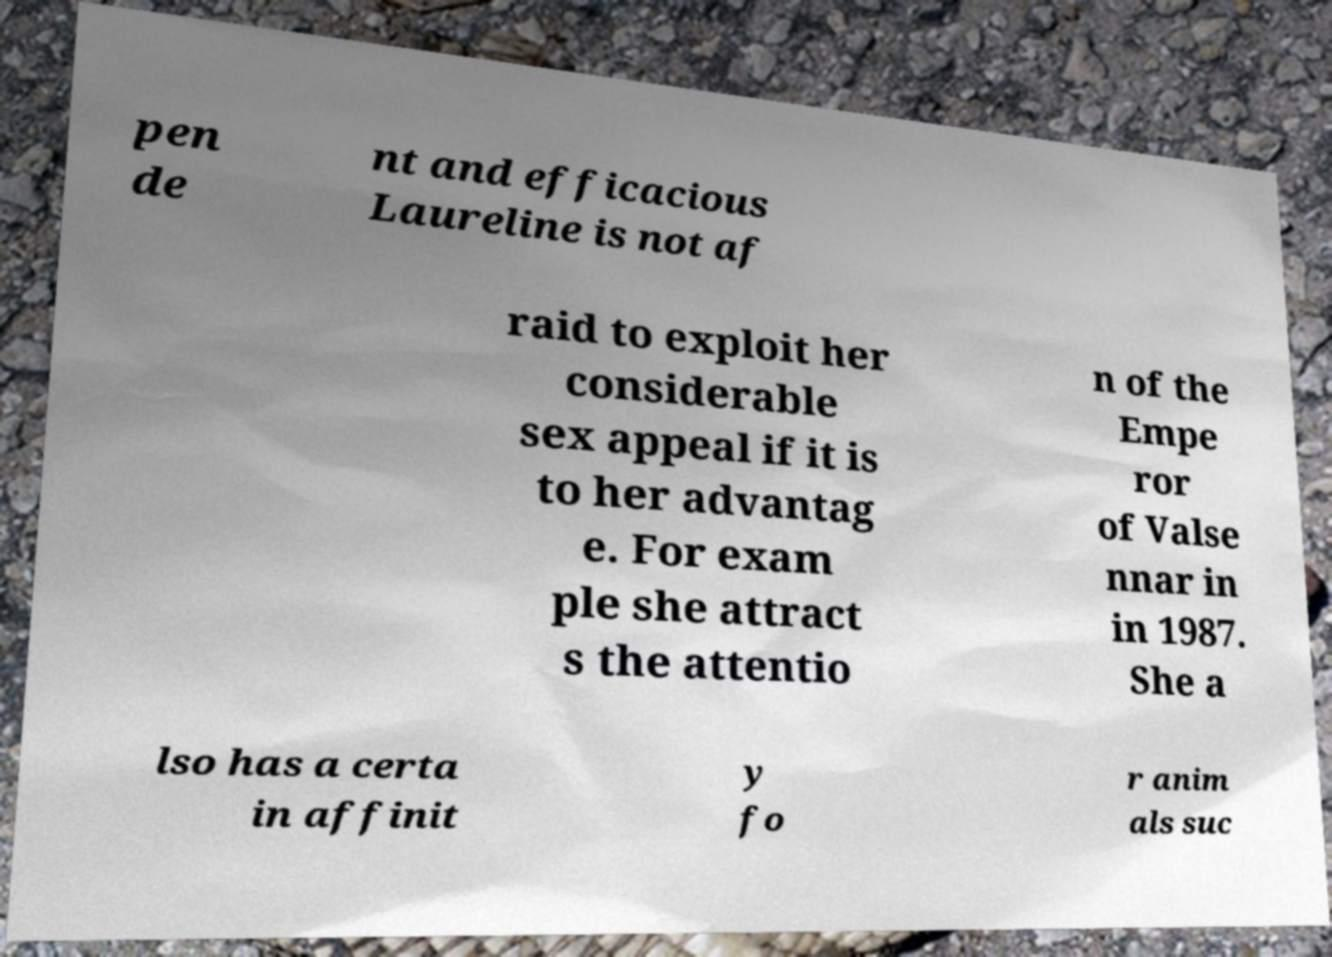For documentation purposes, I need the text within this image transcribed. Could you provide that? pen de nt and efficacious Laureline is not af raid to exploit her considerable sex appeal if it is to her advantag e. For exam ple she attract s the attentio n of the Empe ror of Valse nnar in in 1987. She a lso has a certa in affinit y fo r anim als suc 